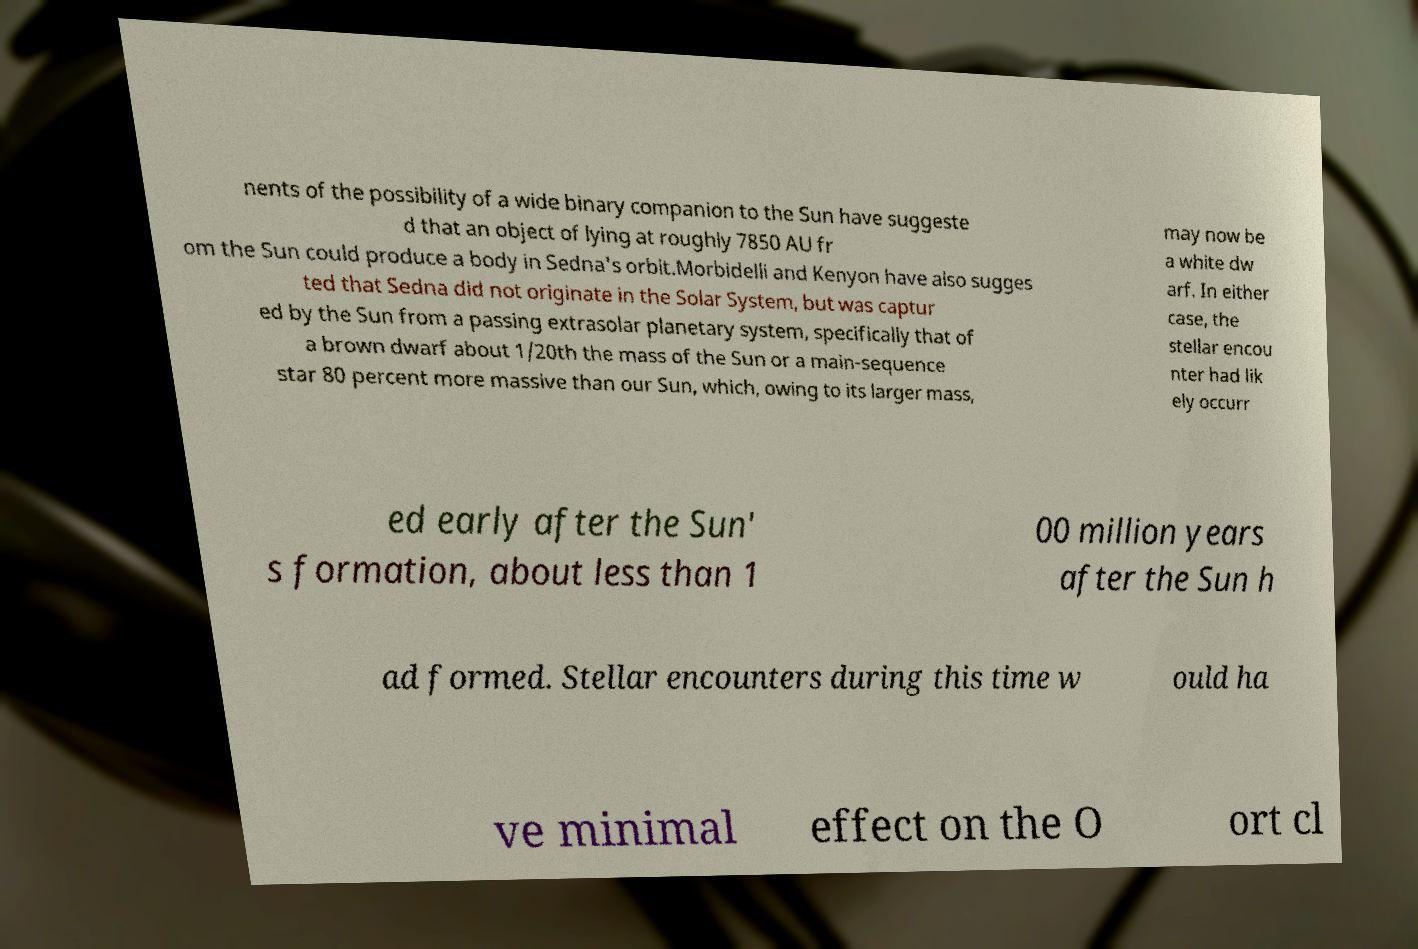What messages or text are displayed in this image? I need them in a readable, typed format. nents of the possibility of a wide binary companion to the Sun have suggeste d that an object of lying at roughly 7850 AU fr om the Sun could produce a body in Sedna's orbit.Morbidelli and Kenyon have also sugges ted that Sedna did not originate in the Solar System, but was captur ed by the Sun from a passing extrasolar planetary system, specifically that of a brown dwarf about 1/20th the mass of the Sun or a main-sequence star 80 percent more massive than our Sun, which, owing to its larger mass, may now be a white dw arf. In either case, the stellar encou nter had lik ely occurr ed early after the Sun' s formation, about less than 1 00 million years after the Sun h ad formed. Stellar encounters during this time w ould ha ve minimal effect on the O ort cl 